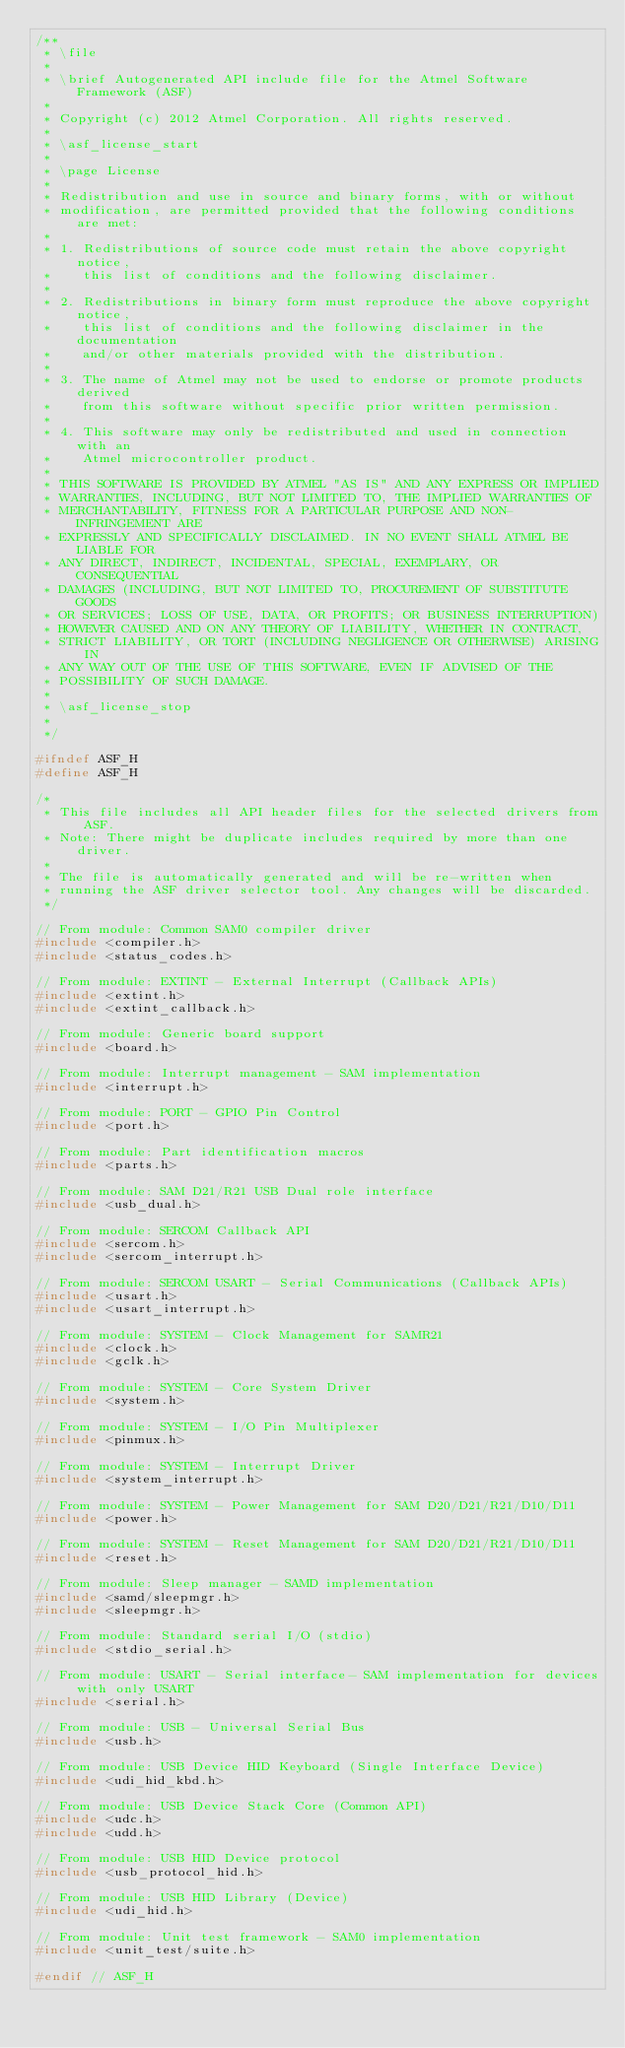Convert code to text. <code><loc_0><loc_0><loc_500><loc_500><_C_>/**
 * \file
 *
 * \brief Autogenerated API include file for the Atmel Software Framework (ASF)
 *
 * Copyright (c) 2012 Atmel Corporation. All rights reserved.
 *
 * \asf_license_start
 *
 * \page License
 *
 * Redistribution and use in source and binary forms, with or without
 * modification, are permitted provided that the following conditions are met:
 *
 * 1. Redistributions of source code must retain the above copyright notice,
 *    this list of conditions and the following disclaimer.
 *
 * 2. Redistributions in binary form must reproduce the above copyright notice,
 *    this list of conditions and the following disclaimer in the documentation
 *    and/or other materials provided with the distribution.
 *
 * 3. The name of Atmel may not be used to endorse or promote products derived
 *    from this software without specific prior written permission.
 *
 * 4. This software may only be redistributed and used in connection with an
 *    Atmel microcontroller product.
 *
 * THIS SOFTWARE IS PROVIDED BY ATMEL "AS IS" AND ANY EXPRESS OR IMPLIED
 * WARRANTIES, INCLUDING, BUT NOT LIMITED TO, THE IMPLIED WARRANTIES OF
 * MERCHANTABILITY, FITNESS FOR A PARTICULAR PURPOSE AND NON-INFRINGEMENT ARE
 * EXPRESSLY AND SPECIFICALLY DISCLAIMED. IN NO EVENT SHALL ATMEL BE LIABLE FOR
 * ANY DIRECT, INDIRECT, INCIDENTAL, SPECIAL, EXEMPLARY, OR CONSEQUENTIAL
 * DAMAGES (INCLUDING, BUT NOT LIMITED TO, PROCUREMENT OF SUBSTITUTE GOODS
 * OR SERVICES; LOSS OF USE, DATA, OR PROFITS; OR BUSINESS INTERRUPTION)
 * HOWEVER CAUSED AND ON ANY THEORY OF LIABILITY, WHETHER IN CONTRACT,
 * STRICT LIABILITY, OR TORT (INCLUDING NEGLIGENCE OR OTHERWISE) ARISING IN
 * ANY WAY OUT OF THE USE OF THIS SOFTWARE, EVEN IF ADVISED OF THE
 * POSSIBILITY OF SUCH DAMAGE.
 *
 * \asf_license_stop
 *
 */

#ifndef ASF_H
#define ASF_H

/*
 * This file includes all API header files for the selected drivers from ASF.
 * Note: There might be duplicate includes required by more than one driver.
 *
 * The file is automatically generated and will be re-written when
 * running the ASF driver selector tool. Any changes will be discarded.
 */

// From module: Common SAM0 compiler driver
#include <compiler.h>
#include <status_codes.h>

// From module: EXTINT - External Interrupt (Callback APIs)
#include <extint.h>
#include <extint_callback.h>

// From module: Generic board support
#include <board.h>

// From module: Interrupt management - SAM implementation
#include <interrupt.h>

// From module: PORT - GPIO Pin Control
#include <port.h>

// From module: Part identification macros
#include <parts.h>

// From module: SAM D21/R21 USB Dual role interface
#include <usb_dual.h>

// From module: SERCOM Callback API
#include <sercom.h>
#include <sercom_interrupt.h>

// From module: SERCOM USART - Serial Communications (Callback APIs)
#include <usart.h>
#include <usart_interrupt.h>

// From module: SYSTEM - Clock Management for SAMR21
#include <clock.h>
#include <gclk.h>

// From module: SYSTEM - Core System Driver
#include <system.h>

// From module: SYSTEM - I/O Pin Multiplexer
#include <pinmux.h>

// From module: SYSTEM - Interrupt Driver
#include <system_interrupt.h>

// From module: SYSTEM - Power Management for SAM D20/D21/R21/D10/D11
#include <power.h>

// From module: SYSTEM - Reset Management for SAM D20/D21/R21/D10/D11
#include <reset.h>

// From module: Sleep manager - SAMD implementation
#include <samd/sleepmgr.h>
#include <sleepmgr.h>

// From module: Standard serial I/O (stdio)
#include <stdio_serial.h>

// From module: USART - Serial interface- SAM implementation for devices with only USART
#include <serial.h>

// From module: USB - Universal Serial Bus
#include <usb.h>

// From module: USB Device HID Keyboard (Single Interface Device)
#include <udi_hid_kbd.h>

// From module: USB Device Stack Core (Common API)
#include <udc.h>
#include <udd.h>

// From module: USB HID Device protocol
#include <usb_protocol_hid.h>

// From module: USB HID Library (Device)
#include <udi_hid.h>

// From module: Unit test framework - SAM0 implementation
#include <unit_test/suite.h>

#endif // ASF_H
</code> 